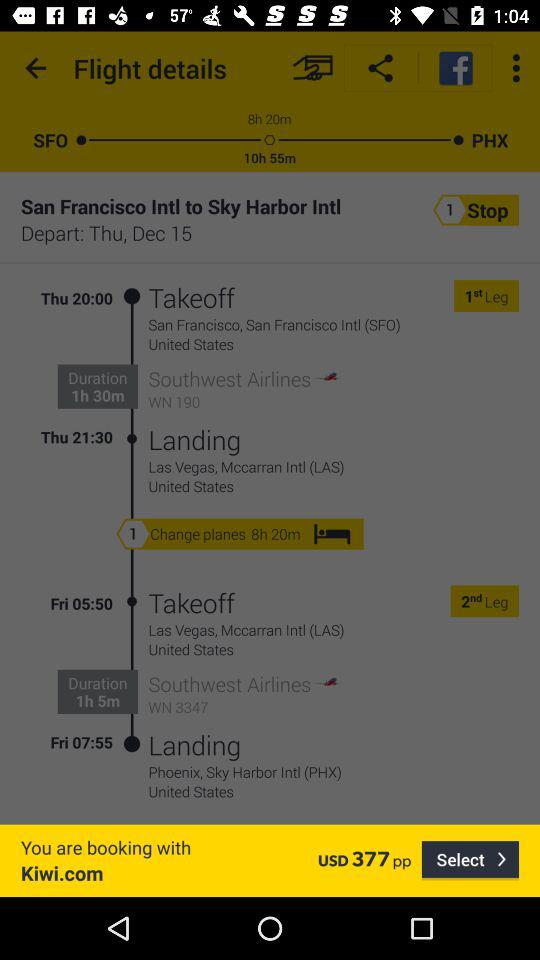What is the booking price? The booking price is USD 377. 